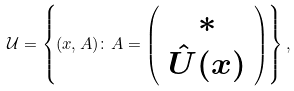Convert formula to latex. <formula><loc_0><loc_0><loc_500><loc_500>\mathcal { U } = \left \{ ( x , A ) \colon A = \left ( \begin{array} { c c } * \\ \hat { U } ( x ) \end{array} \right ) \right \} ,</formula> 